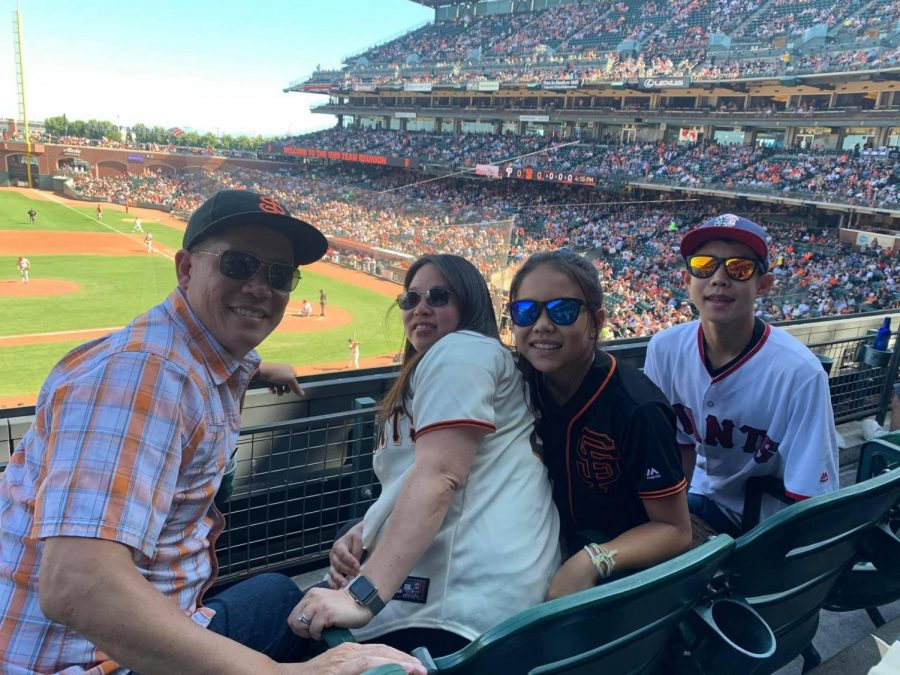Considering the position of the sun and the shadows in the stadium, can we infer the approximate time of day the photo was taken? Based on the shadows cast by the railing and the seats, it's evident that the sun is at a high position, but not directly overhead. This suggests it's most likely early to mid-afternoon, perhaps around 1 PM to 3 PM. The shadows are long enough to indicate the sun is not at the zenith, which aligns with the typical length of shadows during the afternoon in early summer or late spring, suggesting that the photo was likely taken during that period. 